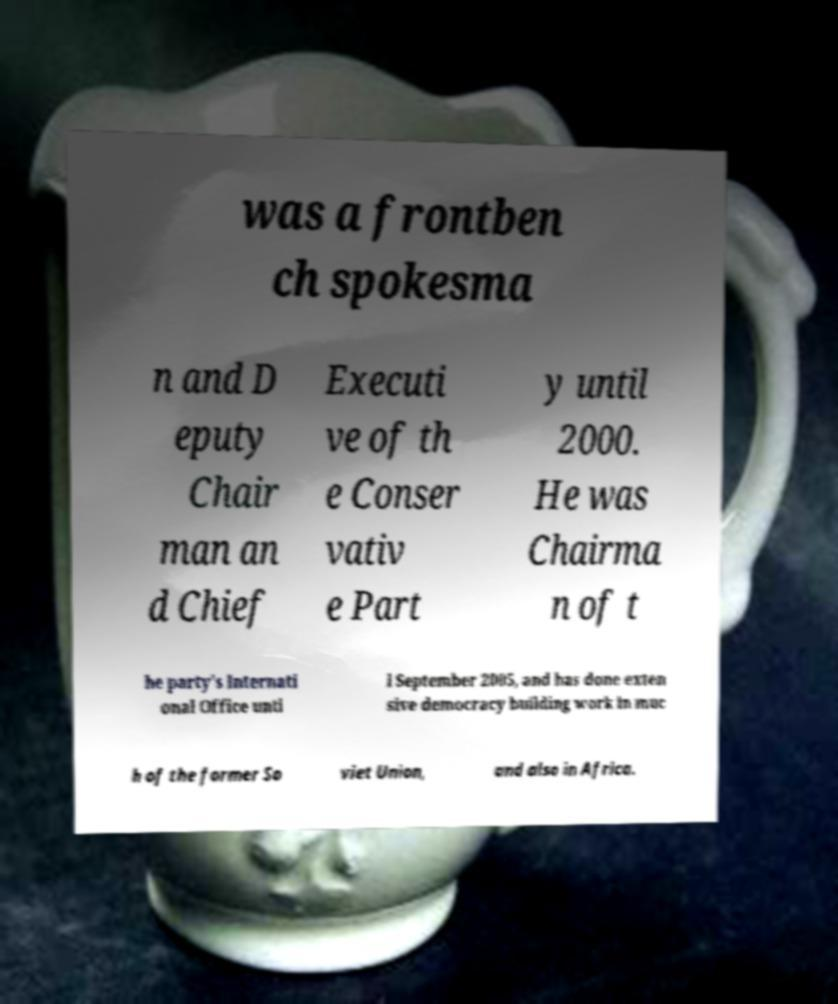There's text embedded in this image that I need extracted. Can you transcribe it verbatim? was a frontben ch spokesma n and D eputy Chair man an d Chief Executi ve of th e Conser vativ e Part y until 2000. He was Chairma n of t he party's Internati onal Office unti l September 2005, and has done exten sive democracy building work in muc h of the former So viet Union, and also in Africa. 